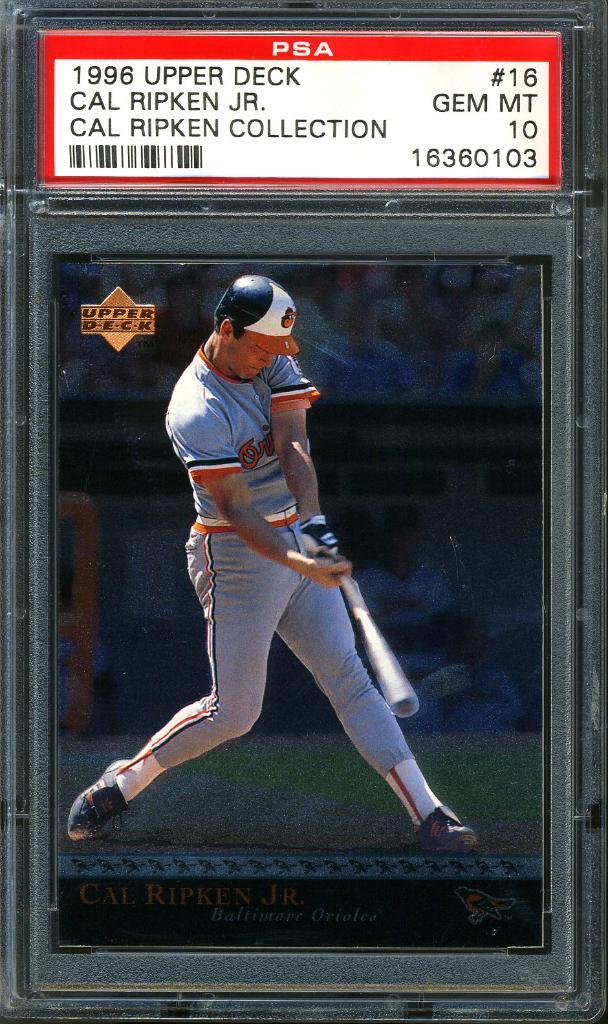<image>
Offer a succinct explanation of the picture presented. A man in a baseball uniform is shown below a label that is titled PSA. 